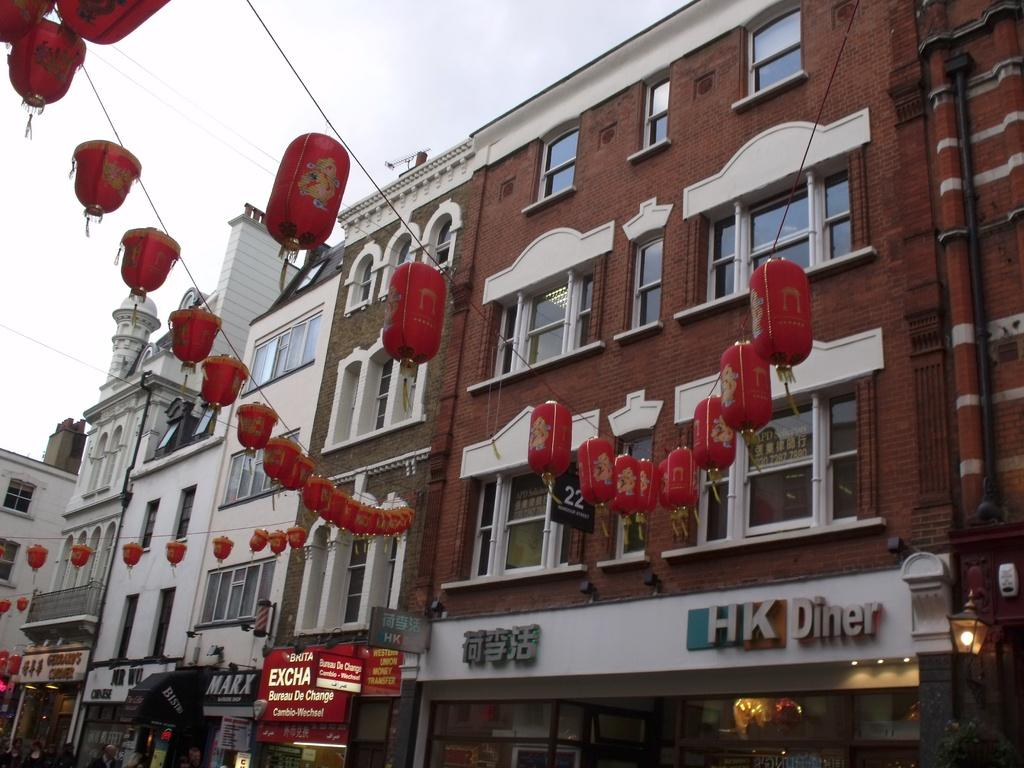What type of lighting fixtures can be seen in the image? There are lanterns and lights in the image. What type of signage is present in the image? There are name boards in the image. What structural elements can be seen in the image? There are pipes and buildings with windows in the image. What other objects are present in the image? There are there any specific details about them? What can be seen in the background of the image? The sky is visible in the background of the image. How many family members are visible in the image? There is no family present in the image; it features lanterns, name boards, lights, pipes, buildings, and other objects. What is the value of the dime seen in the image? There is no dime present in the image. 